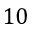<formula> <loc_0><loc_0><loc_500><loc_500>1 0</formula> 